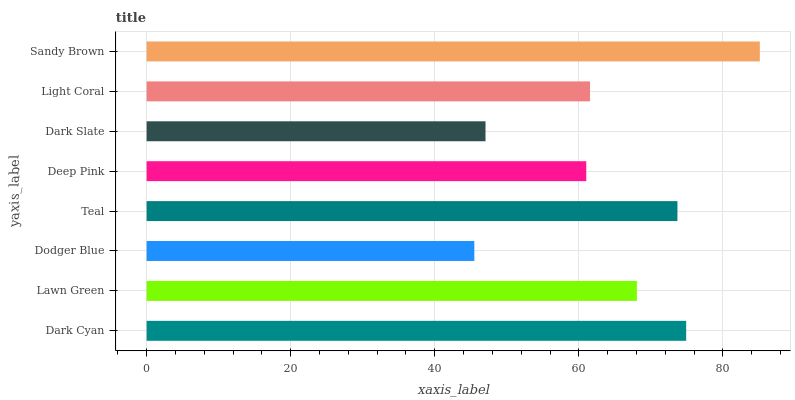Is Dodger Blue the minimum?
Answer yes or no. Yes. Is Sandy Brown the maximum?
Answer yes or no. Yes. Is Lawn Green the minimum?
Answer yes or no. No. Is Lawn Green the maximum?
Answer yes or no. No. Is Dark Cyan greater than Lawn Green?
Answer yes or no. Yes. Is Lawn Green less than Dark Cyan?
Answer yes or no. Yes. Is Lawn Green greater than Dark Cyan?
Answer yes or no. No. Is Dark Cyan less than Lawn Green?
Answer yes or no. No. Is Lawn Green the high median?
Answer yes or no. Yes. Is Light Coral the low median?
Answer yes or no. Yes. Is Dark Slate the high median?
Answer yes or no. No. Is Sandy Brown the low median?
Answer yes or no. No. 